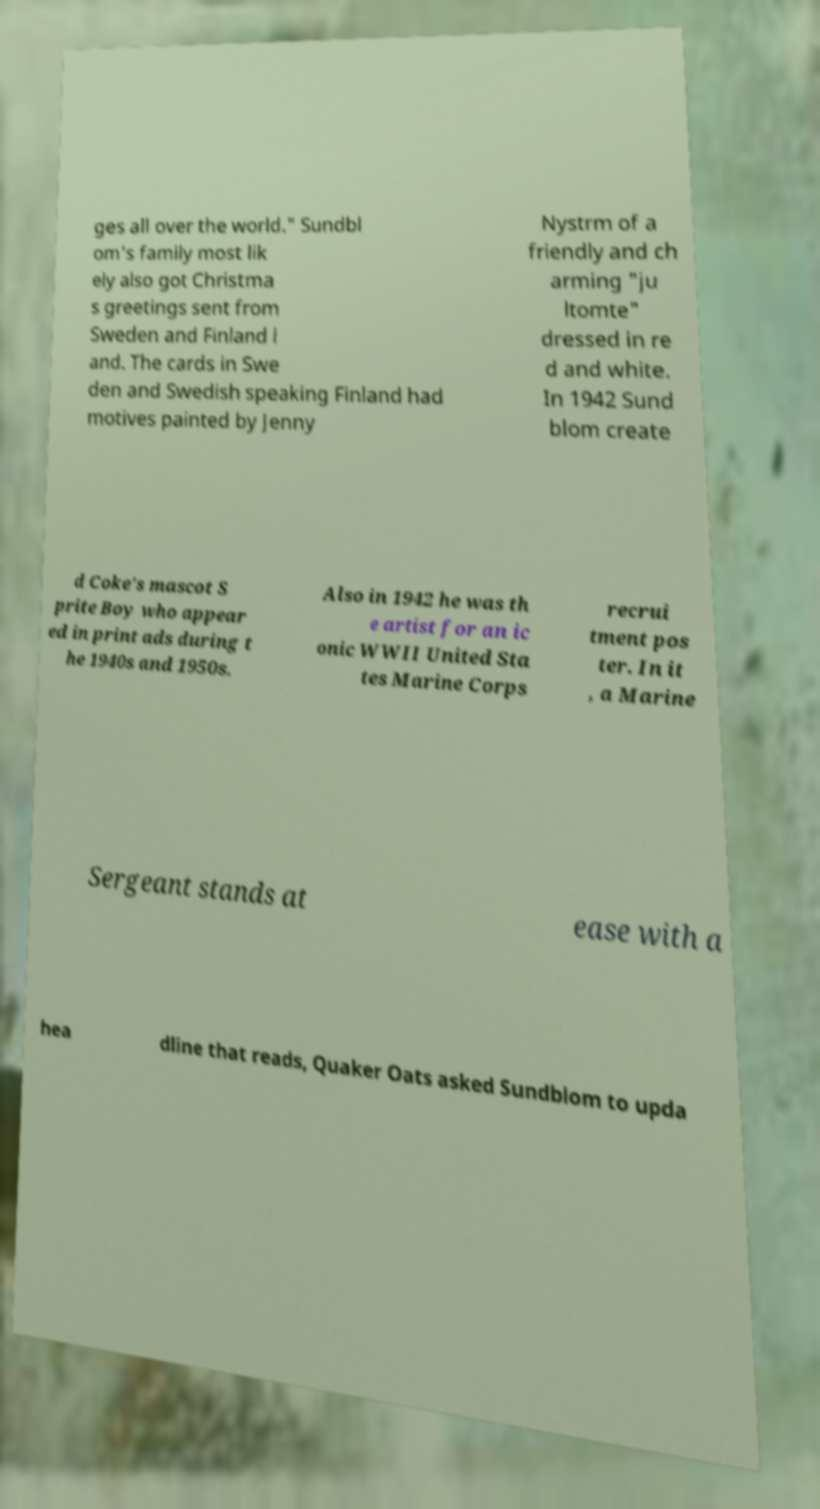Can you read and provide the text displayed in the image?This photo seems to have some interesting text. Can you extract and type it out for me? ges all over the world." Sundbl om's family most lik ely also got Christma s greetings sent from Sweden and Finland l and. The cards in Swe den and Swedish speaking Finland had motives painted by Jenny Nystrm of a friendly and ch arming "ju ltomte" dressed in re d and white. In 1942 Sund blom create d Coke's mascot S prite Boy who appear ed in print ads during t he 1940s and 1950s. Also in 1942 he was th e artist for an ic onic WWII United Sta tes Marine Corps recrui tment pos ter. In it , a Marine Sergeant stands at ease with a hea dline that reads, Quaker Oats asked Sundblom to upda 